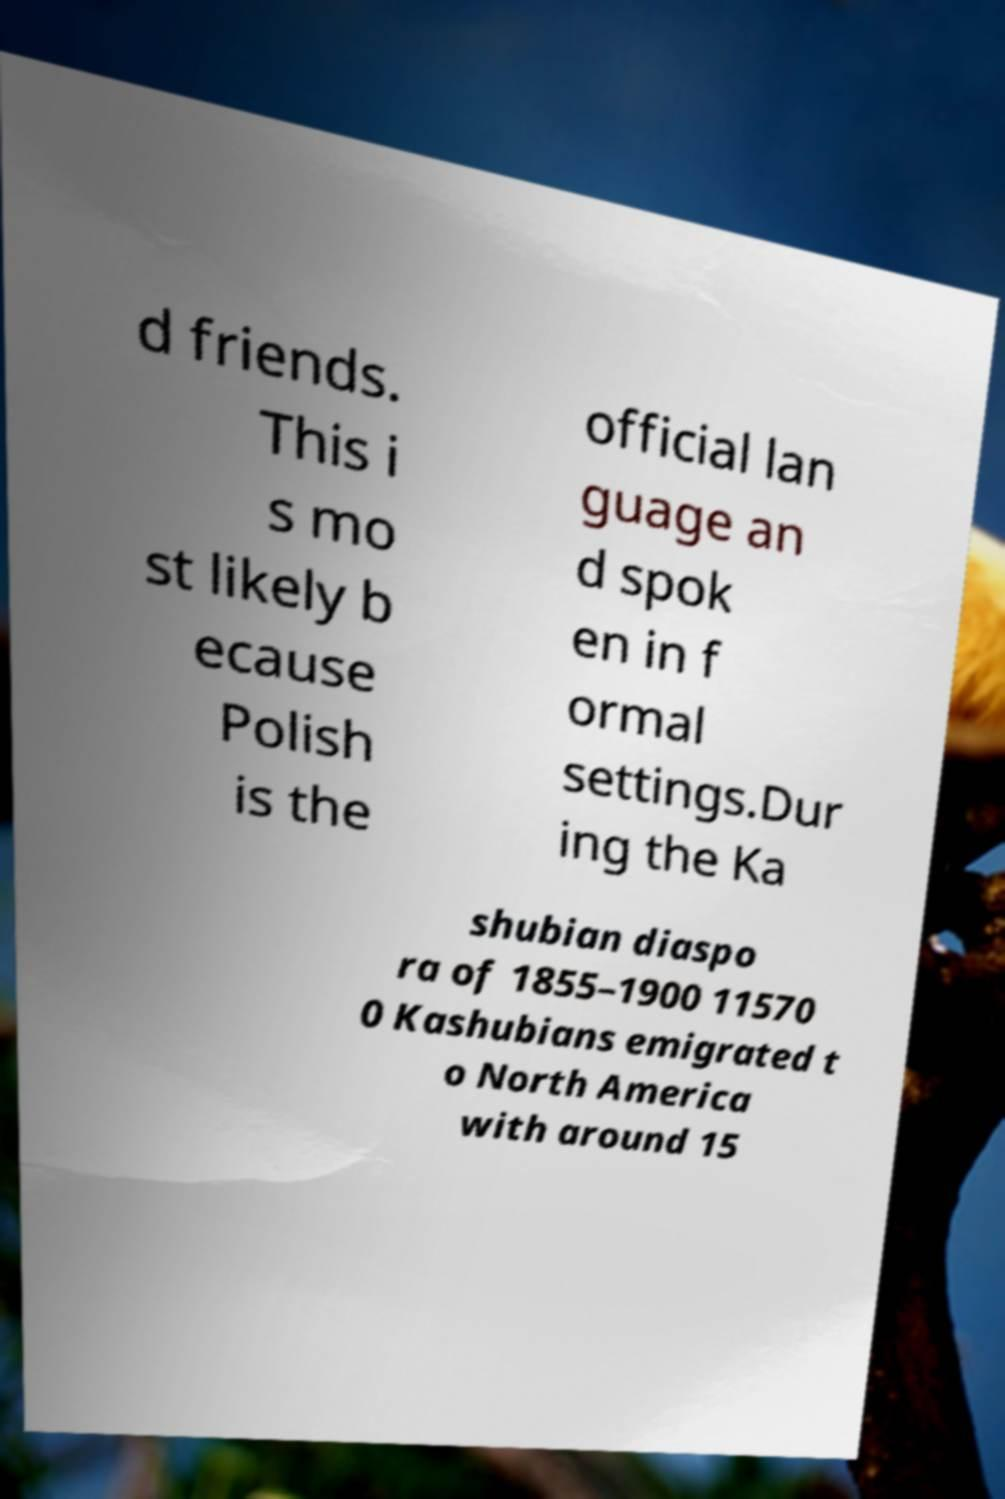There's text embedded in this image that I need extracted. Can you transcribe it verbatim? d friends. This i s mo st likely b ecause Polish is the official lan guage an d spok en in f ormal settings.Dur ing the Ka shubian diaspo ra of 1855–1900 11570 0 Kashubians emigrated t o North America with around 15 